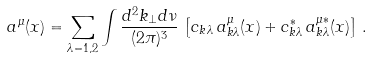<formula> <loc_0><loc_0><loc_500><loc_500>a ^ { \mu } ( x ) = \sum _ { \lambda = 1 , 2 } \int \frac { d ^ { 2 } k _ { \perp } d \nu } { ( 2 \pi ) ^ { 3 } } \, \left [ c _ { k \lambda } \, a _ { k \lambda } ^ { \mu } ( x ) + c _ { k \lambda } ^ { * } \, a _ { k \lambda } ^ { \mu * } ( x ) \right ] \, .</formula> 